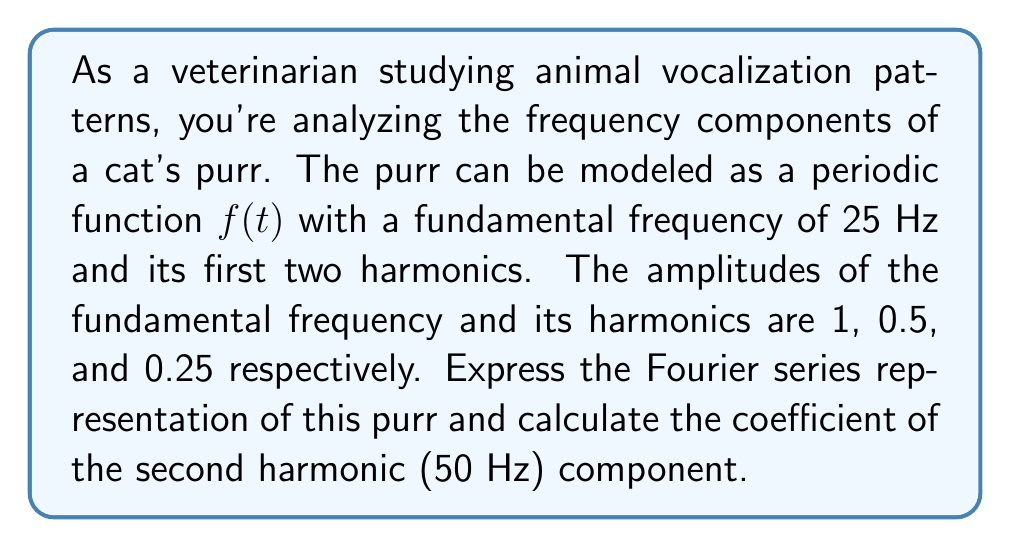Can you solve this math problem? Let's approach this step-by-step:

1) The Fourier series for a periodic function can be expressed as:

   $$f(t) = a_0 + \sum_{n=1}^{\infty} [a_n \cos(n\omega_0 t) + b_n \sin(n\omega_0 t)]$$

   where $\omega_0 = 2\pi f_0$ is the fundamental angular frequency.

2) In this case, $f_0 = 25$ Hz, so $\omega_0 = 2\pi(25) = 50\pi$ rad/s.

3) We're told that the purr consists of the fundamental frequency and its first two harmonics. This means we need terms for $n = 1, 2, 3$.

4) The amplitudes are given as 1, 0.5, and 0.25 for the fundamental and two harmonics respectively. These correspond to the coefficients in the Fourier series.

5) Assuming the purr starts at maximum amplitude at $t=0$ (cosine phase), we can write:

   $$f(t) = \cos(50\pi t) + 0.5\cos(100\pi t) + 0.25\cos(150\pi t)$$

6) Comparing this to the general Fourier series form:

   $$f(t) = a_1 \cos(\omega_0 t) + a_2 \cos(2\omega_0 t) + a_3 \cos(3\omega_0 t)$$

7) We can identify that $a_1 = 1$, $a_2 = 0.5$, and $a_3 = 0.25$.

8) The question asks for the coefficient of the second harmonic (50 Hz) component, which is $a_2 = 0.5$.
Answer: The coefficient of the second harmonic (50 Hz) component is 0.5. 